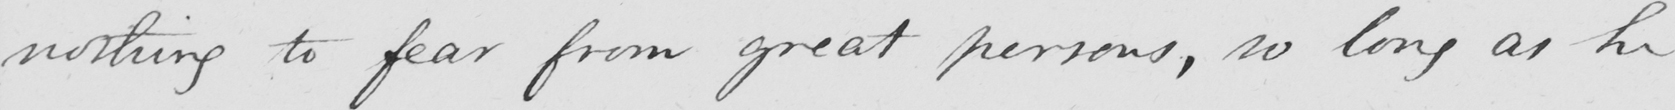What does this handwritten line say? nothing to fear from great persons , so long as he 